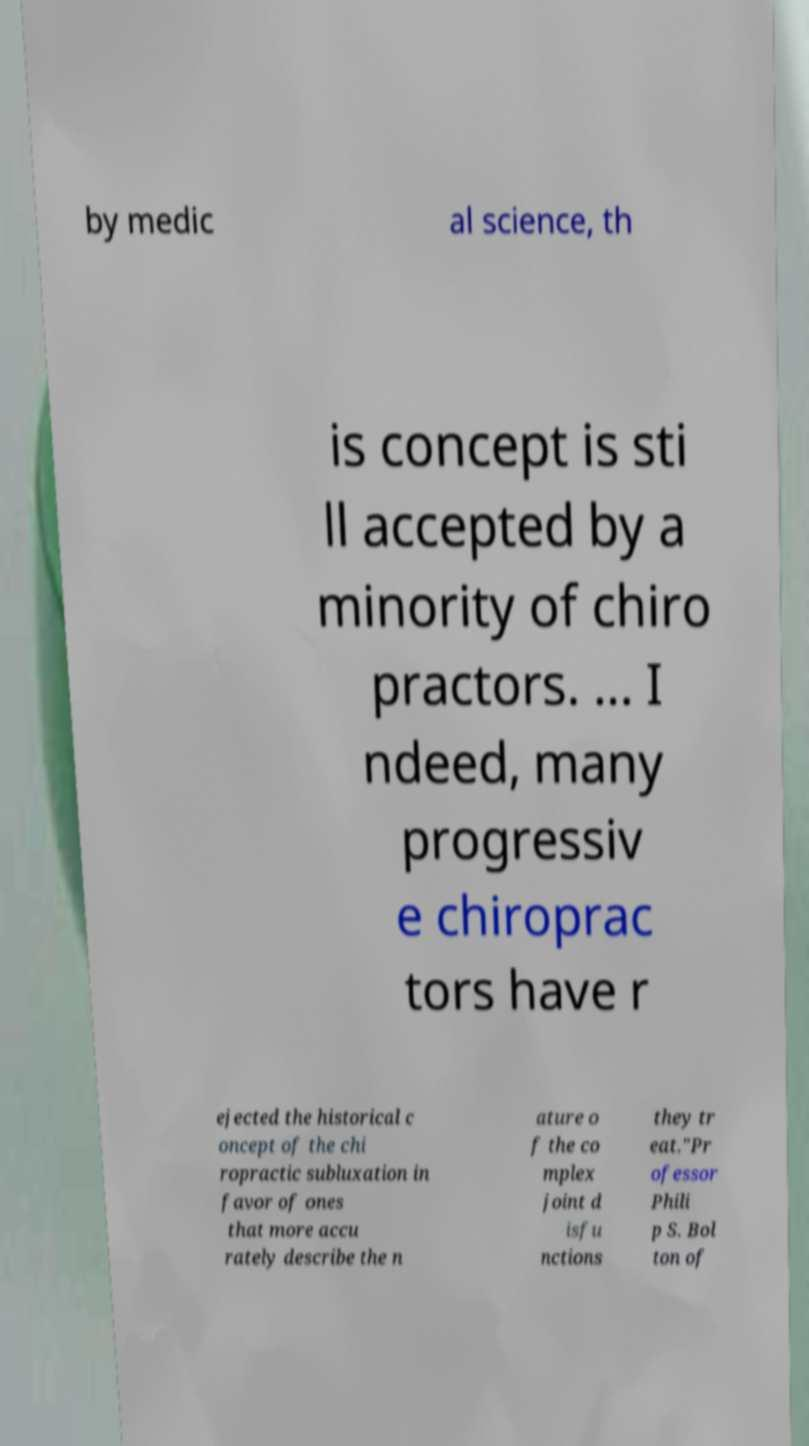What messages or text are displayed in this image? I need them in a readable, typed format. by medic al science, th is concept is sti ll accepted by a minority of chiro practors. ... I ndeed, many progressiv e chiroprac tors have r ejected the historical c oncept of the chi ropractic subluxation in favor of ones that more accu rately describe the n ature o f the co mplex joint d isfu nctions they tr eat."Pr ofessor Phili p S. Bol ton of 